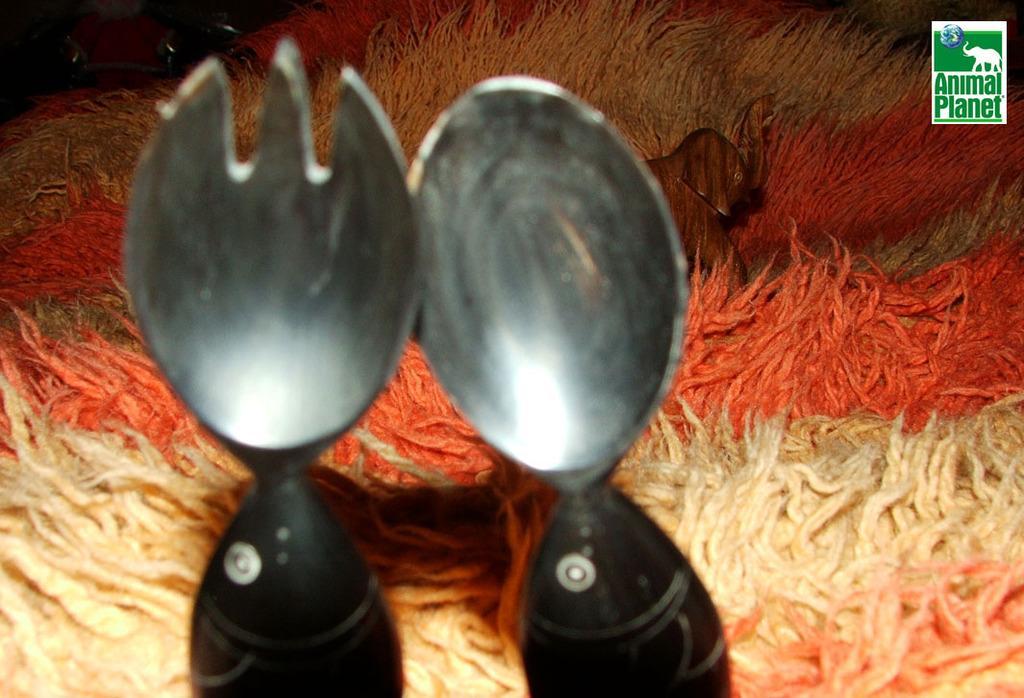Describe this image in one or two sentences. In the image there is a spoon and fork. Behind them there is woolen cloth with an image of an elephant. In the top right corner of the image there is a logo. 